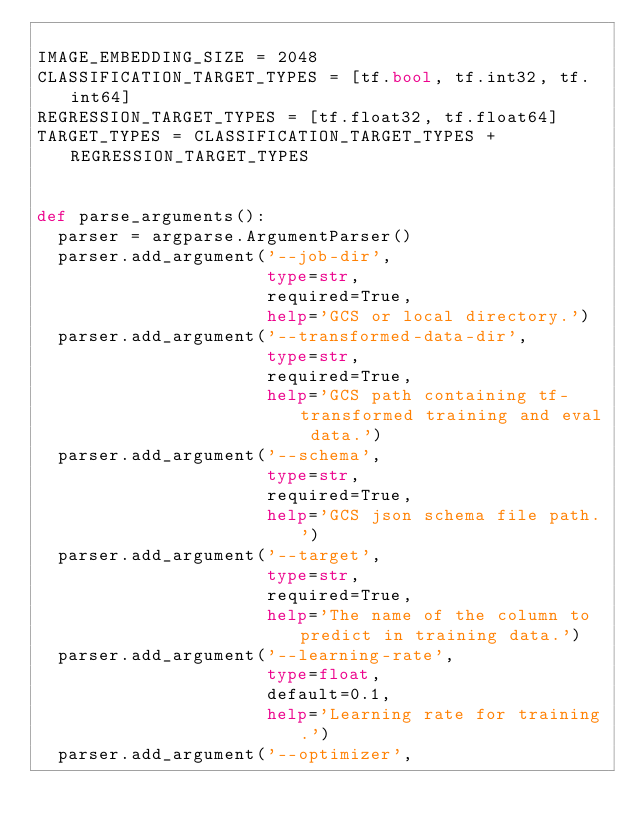Convert code to text. <code><loc_0><loc_0><loc_500><loc_500><_Python_>
IMAGE_EMBEDDING_SIZE = 2048
CLASSIFICATION_TARGET_TYPES = [tf.bool, tf.int32, tf.int64]
REGRESSION_TARGET_TYPES = [tf.float32, tf.float64]
TARGET_TYPES = CLASSIFICATION_TARGET_TYPES + REGRESSION_TARGET_TYPES


def parse_arguments():
  parser = argparse.ArgumentParser()
  parser.add_argument('--job-dir',
                      type=str,
                      required=True,
                      help='GCS or local directory.')
  parser.add_argument('--transformed-data-dir',
                      type=str,
                      required=True,
                      help='GCS path containing tf-transformed training and eval data.')
  parser.add_argument('--schema',
                      type=str,
                      required=True,
                      help='GCS json schema file path.')
  parser.add_argument('--target',
                      type=str,
                      required=True,
                      help='The name of the column to predict in training data.')
  parser.add_argument('--learning-rate',
                      type=float,
                      default=0.1,
                      help='Learning rate for training.')
  parser.add_argument('--optimizer',</code> 